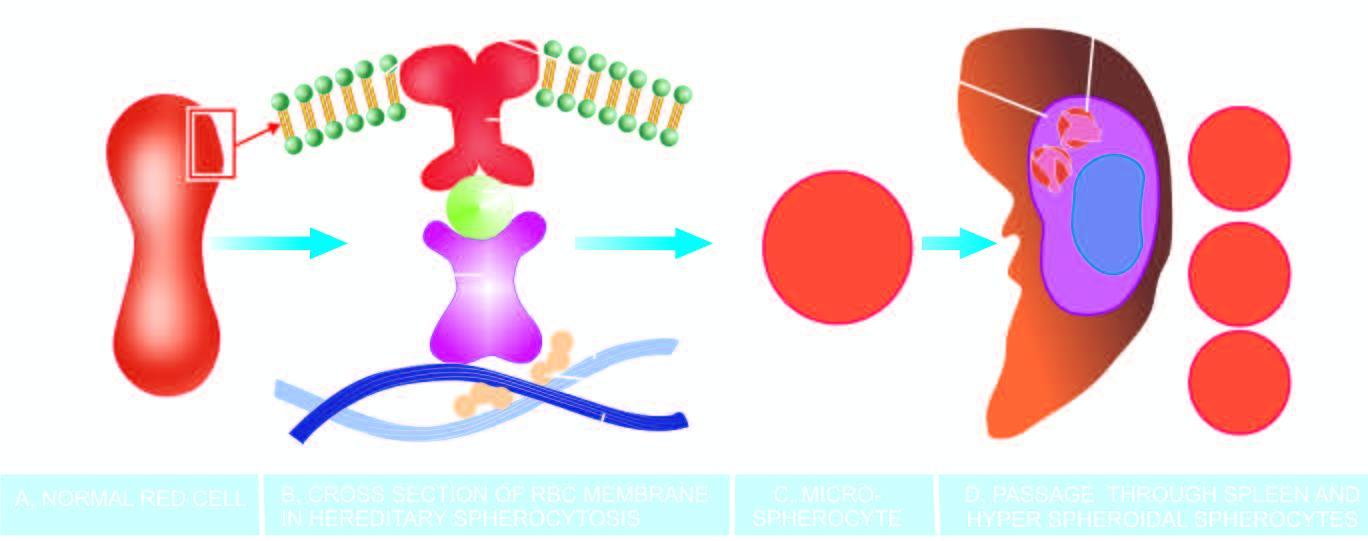what result in defect in anchoring of lipid bilayer of the membrane to the underlying cytoskeleton?
Answer the question using a single word or phrase. Mutations in membrane proteins-alpha-spectrin 